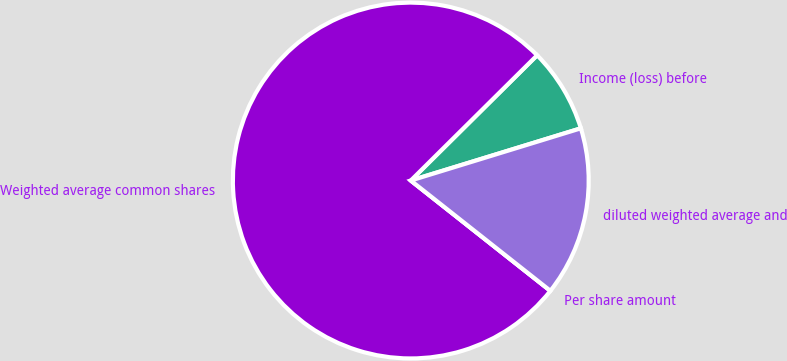Convert chart to OTSL. <chart><loc_0><loc_0><loc_500><loc_500><pie_chart><fcel>Income (loss) before<fcel>Weighted average common shares<fcel>Per share amount<fcel>diluted weighted average and<nl><fcel>7.69%<fcel>76.92%<fcel>0.0%<fcel>15.38%<nl></chart> 